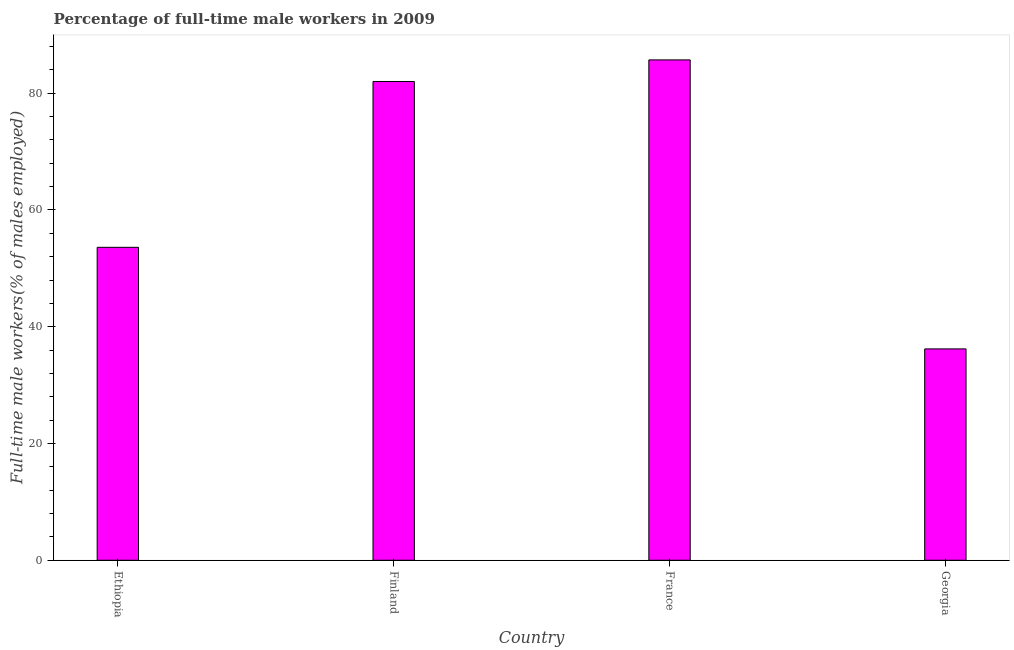Does the graph contain grids?
Keep it short and to the point. No. What is the title of the graph?
Offer a very short reply. Percentage of full-time male workers in 2009. What is the label or title of the X-axis?
Provide a succinct answer. Country. What is the label or title of the Y-axis?
Offer a very short reply. Full-time male workers(% of males employed). What is the percentage of full-time male workers in France?
Offer a terse response. 85.7. Across all countries, what is the maximum percentage of full-time male workers?
Make the answer very short. 85.7. Across all countries, what is the minimum percentage of full-time male workers?
Make the answer very short. 36.2. In which country was the percentage of full-time male workers maximum?
Offer a terse response. France. In which country was the percentage of full-time male workers minimum?
Ensure brevity in your answer.  Georgia. What is the sum of the percentage of full-time male workers?
Your response must be concise. 257.5. What is the difference between the percentage of full-time male workers in Ethiopia and Finland?
Your answer should be compact. -28.4. What is the average percentage of full-time male workers per country?
Provide a short and direct response. 64.38. What is the median percentage of full-time male workers?
Provide a succinct answer. 67.8. What is the ratio of the percentage of full-time male workers in Ethiopia to that in Georgia?
Your answer should be compact. 1.48. Is the sum of the percentage of full-time male workers in Finland and France greater than the maximum percentage of full-time male workers across all countries?
Ensure brevity in your answer.  Yes. What is the difference between the highest and the lowest percentage of full-time male workers?
Ensure brevity in your answer.  49.5. How many bars are there?
Your response must be concise. 4. Are all the bars in the graph horizontal?
Offer a terse response. No. How many countries are there in the graph?
Give a very brief answer. 4. What is the Full-time male workers(% of males employed) in Ethiopia?
Ensure brevity in your answer.  53.6. What is the Full-time male workers(% of males employed) in France?
Offer a very short reply. 85.7. What is the Full-time male workers(% of males employed) of Georgia?
Offer a very short reply. 36.2. What is the difference between the Full-time male workers(% of males employed) in Ethiopia and Finland?
Provide a succinct answer. -28.4. What is the difference between the Full-time male workers(% of males employed) in Ethiopia and France?
Your answer should be very brief. -32.1. What is the difference between the Full-time male workers(% of males employed) in Finland and France?
Provide a succinct answer. -3.7. What is the difference between the Full-time male workers(% of males employed) in Finland and Georgia?
Make the answer very short. 45.8. What is the difference between the Full-time male workers(% of males employed) in France and Georgia?
Offer a terse response. 49.5. What is the ratio of the Full-time male workers(% of males employed) in Ethiopia to that in Finland?
Offer a terse response. 0.65. What is the ratio of the Full-time male workers(% of males employed) in Ethiopia to that in France?
Offer a terse response. 0.62. What is the ratio of the Full-time male workers(% of males employed) in Ethiopia to that in Georgia?
Ensure brevity in your answer.  1.48. What is the ratio of the Full-time male workers(% of males employed) in Finland to that in Georgia?
Ensure brevity in your answer.  2.27. What is the ratio of the Full-time male workers(% of males employed) in France to that in Georgia?
Provide a short and direct response. 2.37. 